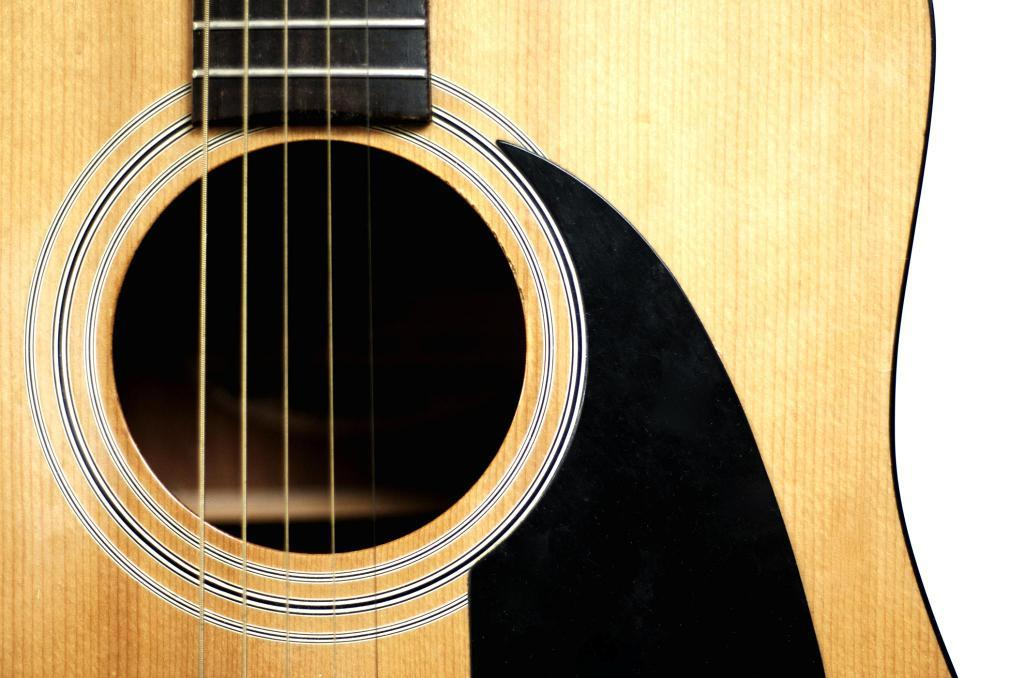What musical instrument is present in the image? There is a guitar in the image. What feature of the guitar is mentioned in the facts? The guitar has strings. What is the tax rate on the guitar in the image? There is no information about tax rates in the image or the facts provided. What arithmetic problem can be solved using the guitar in the image? The image does not depict an arithmetic problem or any mathematical elements. 